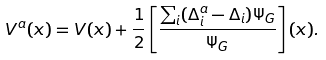Convert formula to latex. <formula><loc_0><loc_0><loc_500><loc_500>V ^ { a } ( x ) = V ( x ) + \frac { 1 } { 2 } \left [ \frac { \sum _ { i } ( \Delta ^ { a } _ { i } - \Delta _ { i } ) \Psi _ { G } } { \Psi _ { G } } \right ] ( x ) .</formula> 